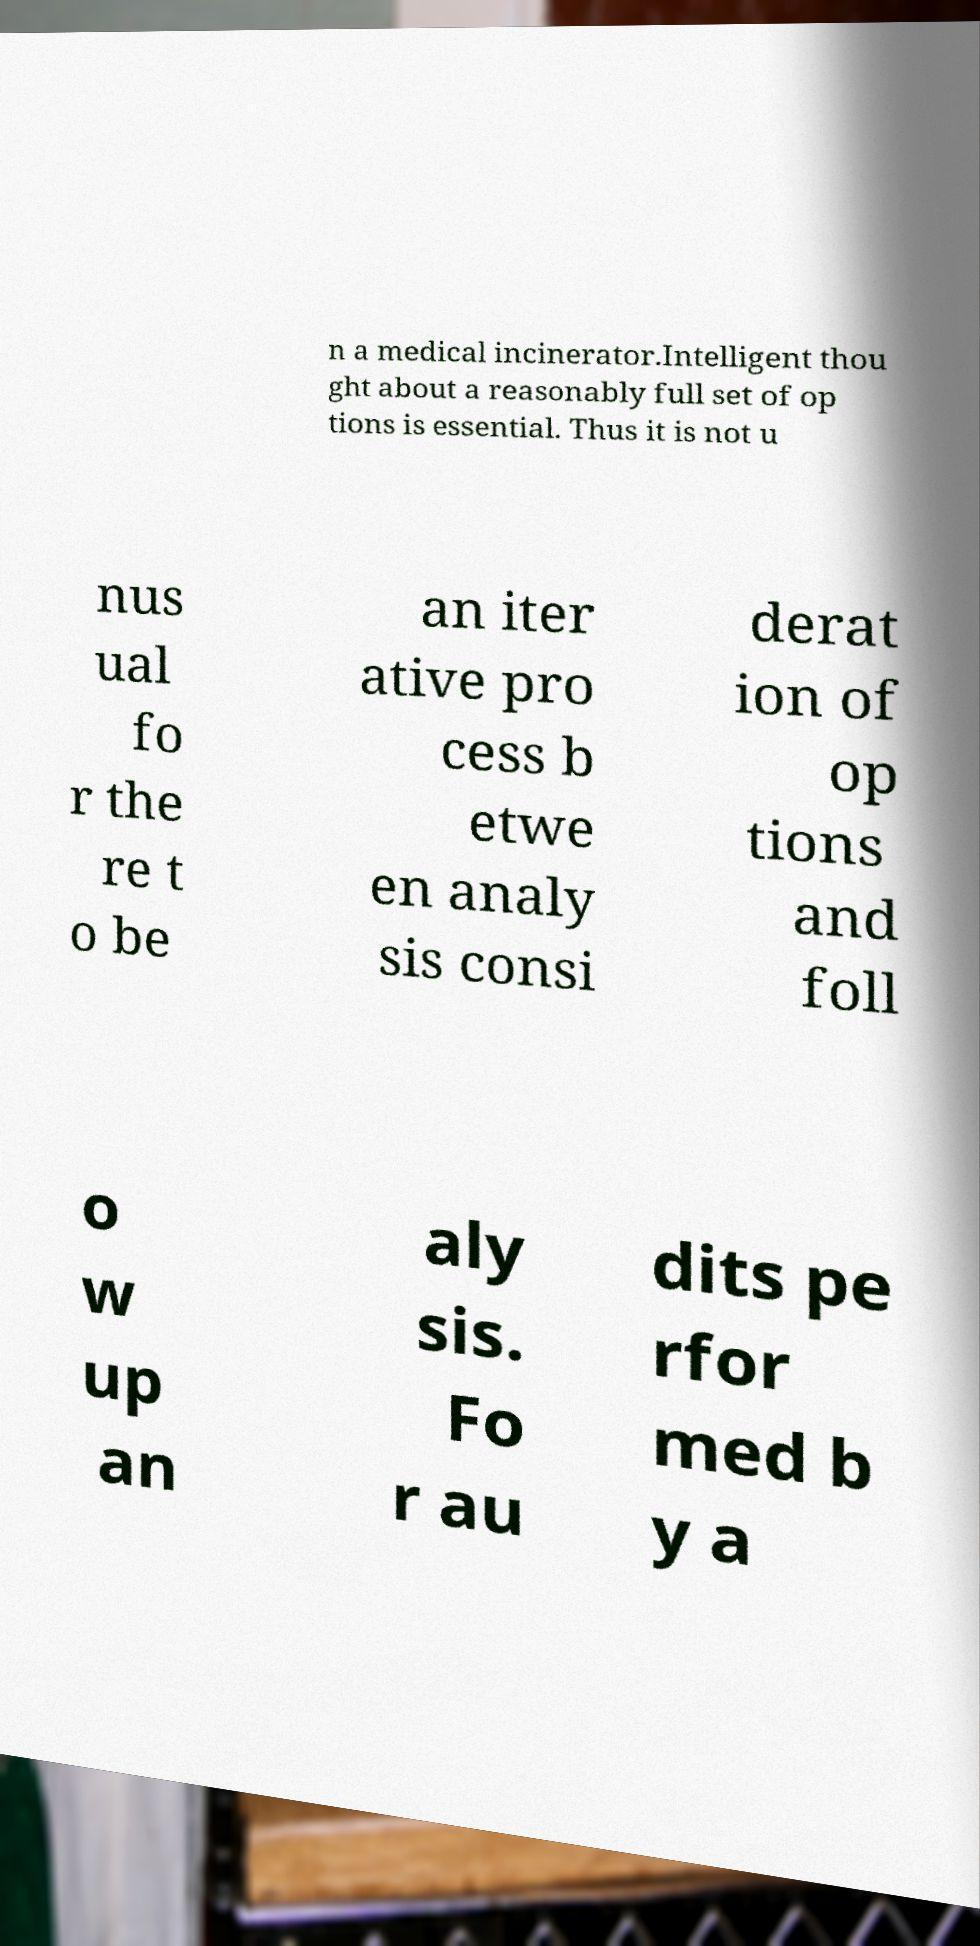Please read and relay the text visible in this image. What does it say? n a medical incinerator.Intelligent thou ght about a reasonably full set of op tions is essential. Thus it is not u nus ual fo r the re t o be an iter ative pro cess b etwe en analy sis consi derat ion of op tions and foll o w up an aly sis. Fo r au dits pe rfor med b y a 